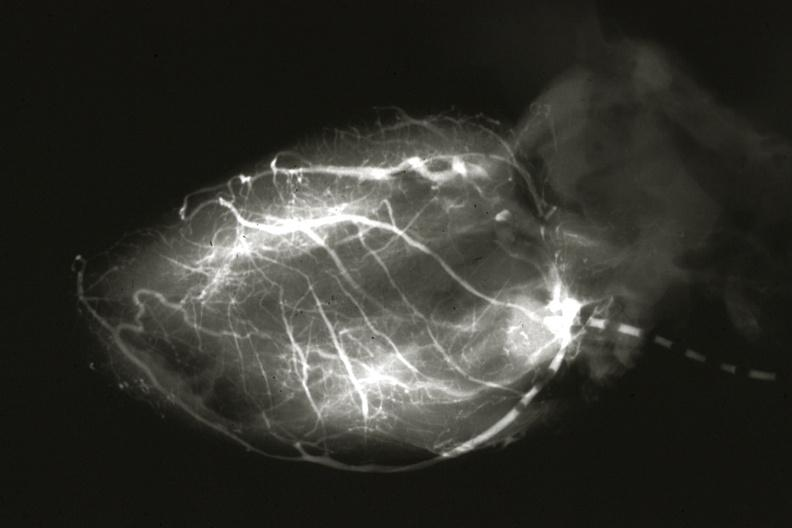s an opened peritoneal cavity cause by fibrous band strangulation present?
Answer the question using a single word or phrase. No 